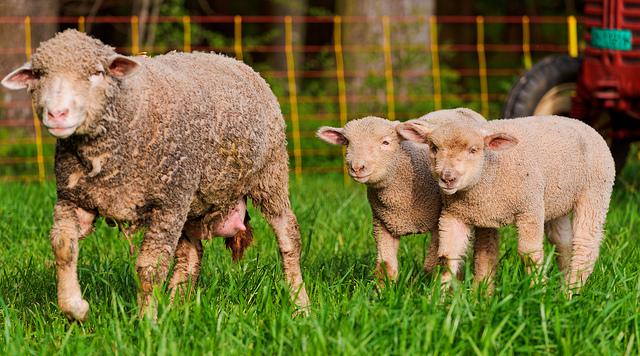Do the sheep need to be shaved?
Be succinct. No. How many baby sheep are in the picture?
Give a very brief answer. 2. What vehicle is behind the animals?
Give a very brief answer. Tractor. 